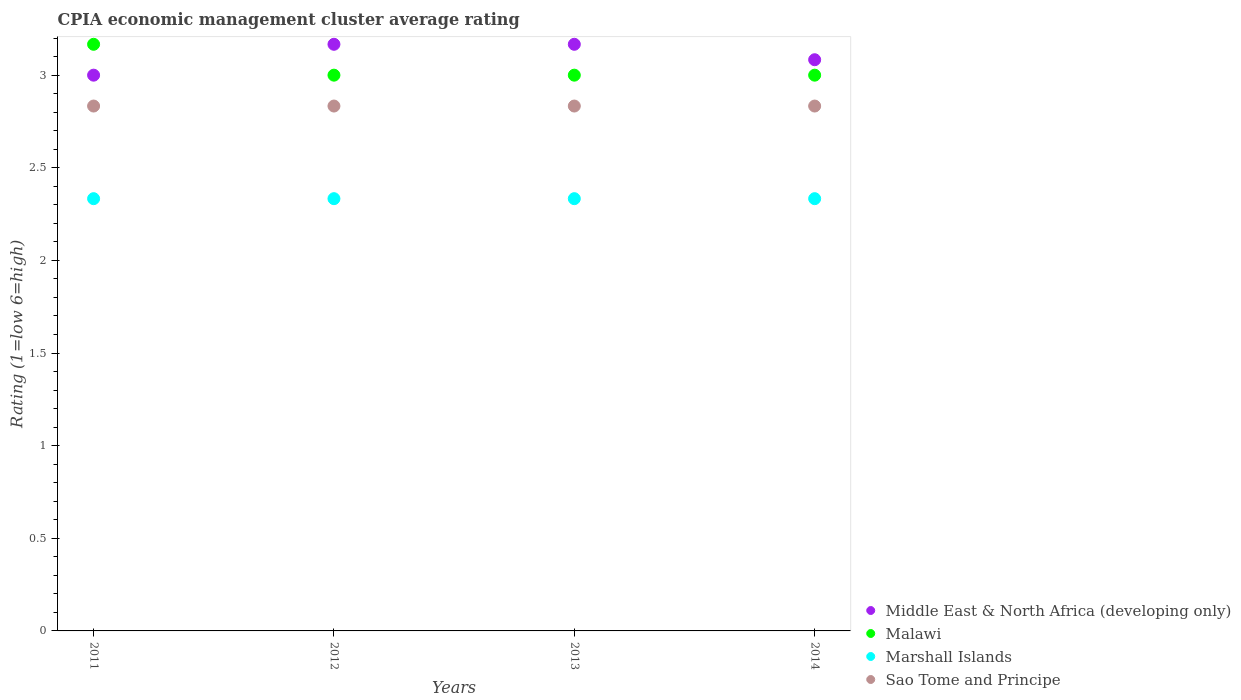How many different coloured dotlines are there?
Give a very brief answer. 4. Is the number of dotlines equal to the number of legend labels?
Keep it short and to the point. Yes. Across all years, what is the maximum CPIA rating in Malawi?
Provide a succinct answer. 3.17. Across all years, what is the minimum CPIA rating in Middle East & North Africa (developing only)?
Your answer should be compact. 3. In which year was the CPIA rating in Malawi minimum?
Make the answer very short. 2012. What is the total CPIA rating in Sao Tome and Principe in the graph?
Provide a short and direct response. 11.33. What is the difference between the CPIA rating in Sao Tome and Principe in 2011 and that in 2013?
Provide a succinct answer. 0. What is the difference between the CPIA rating in Malawi in 2011 and the CPIA rating in Marshall Islands in 2012?
Keep it short and to the point. 0.83. What is the average CPIA rating in Malawi per year?
Your answer should be very brief. 3.04. In the year 2011, what is the difference between the CPIA rating in Malawi and CPIA rating in Marshall Islands?
Your answer should be very brief. 0.83. In how many years, is the CPIA rating in Sao Tome and Principe greater than 2.2?
Ensure brevity in your answer.  4. What is the ratio of the CPIA rating in Malawi in 2011 to that in 2013?
Keep it short and to the point. 1.06. What is the difference between the highest and the second highest CPIA rating in Malawi?
Your response must be concise. 0.17. What is the difference between the highest and the lowest CPIA rating in Sao Tome and Principe?
Your answer should be very brief. 3.333333329802457e-6. Is it the case that in every year, the sum of the CPIA rating in Sao Tome and Principe and CPIA rating in Marshall Islands  is greater than the sum of CPIA rating in Malawi and CPIA rating in Middle East & North Africa (developing only)?
Give a very brief answer. Yes. Does the CPIA rating in Middle East & North Africa (developing only) monotonically increase over the years?
Make the answer very short. No. Is the CPIA rating in Malawi strictly less than the CPIA rating in Marshall Islands over the years?
Offer a very short reply. No. Are the values on the major ticks of Y-axis written in scientific E-notation?
Provide a short and direct response. No. Does the graph contain any zero values?
Offer a terse response. No. What is the title of the graph?
Your answer should be very brief. CPIA economic management cluster average rating. Does "Tunisia" appear as one of the legend labels in the graph?
Offer a very short reply. No. What is the Rating (1=low 6=high) in Malawi in 2011?
Your answer should be very brief. 3.17. What is the Rating (1=low 6=high) of Marshall Islands in 2011?
Ensure brevity in your answer.  2.33. What is the Rating (1=low 6=high) in Sao Tome and Principe in 2011?
Give a very brief answer. 2.83. What is the Rating (1=low 6=high) of Middle East & North Africa (developing only) in 2012?
Ensure brevity in your answer.  3.17. What is the Rating (1=low 6=high) of Marshall Islands in 2012?
Your answer should be very brief. 2.33. What is the Rating (1=low 6=high) in Sao Tome and Principe in 2012?
Provide a succinct answer. 2.83. What is the Rating (1=low 6=high) in Middle East & North Africa (developing only) in 2013?
Provide a short and direct response. 3.17. What is the Rating (1=low 6=high) in Marshall Islands in 2013?
Your response must be concise. 2.33. What is the Rating (1=low 6=high) in Sao Tome and Principe in 2013?
Keep it short and to the point. 2.83. What is the Rating (1=low 6=high) in Middle East & North Africa (developing only) in 2014?
Your response must be concise. 3.08. What is the Rating (1=low 6=high) in Marshall Islands in 2014?
Offer a very short reply. 2.33. What is the Rating (1=low 6=high) of Sao Tome and Principe in 2014?
Your answer should be compact. 2.83. Across all years, what is the maximum Rating (1=low 6=high) in Middle East & North Africa (developing only)?
Provide a succinct answer. 3.17. Across all years, what is the maximum Rating (1=low 6=high) of Malawi?
Keep it short and to the point. 3.17. Across all years, what is the maximum Rating (1=low 6=high) of Marshall Islands?
Keep it short and to the point. 2.33. Across all years, what is the maximum Rating (1=low 6=high) of Sao Tome and Principe?
Make the answer very short. 2.83. Across all years, what is the minimum Rating (1=low 6=high) of Middle East & North Africa (developing only)?
Provide a succinct answer. 3. Across all years, what is the minimum Rating (1=low 6=high) of Malawi?
Ensure brevity in your answer.  3. Across all years, what is the minimum Rating (1=low 6=high) of Marshall Islands?
Provide a short and direct response. 2.33. Across all years, what is the minimum Rating (1=low 6=high) in Sao Tome and Principe?
Your response must be concise. 2.83. What is the total Rating (1=low 6=high) in Middle East & North Africa (developing only) in the graph?
Offer a very short reply. 12.42. What is the total Rating (1=low 6=high) in Malawi in the graph?
Keep it short and to the point. 12.17. What is the total Rating (1=low 6=high) in Marshall Islands in the graph?
Your response must be concise. 9.33. What is the total Rating (1=low 6=high) of Sao Tome and Principe in the graph?
Keep it short and to the point. 11.33. What is the difference between the Rating (1=low 6=high) in Middle East & North Africa (developing only) in 2011 and that in 2012?
Offer a very short reply. -0.17. What is the difference between the Rating (1=low 6=high) of Malawi in 2011 and that in 2012?
Your answer should be compact. 0.17. What is the difference between the Rating (1=low 6=high) of Marshall Islands in 2011 and that in 2012?
Offer a very short reply. 0. What is the difference between the Rating (1=low 6=high) in Sao Tome and Principe in 2011 and that in 2013?
Offer a very short reply. 0. What is the difference between the Rating (1=low 6=high) of Middle East & North Africa (developing only) in 2011 and that in 2014?
Provide a succinct answer. -0.08. What is the difference between the Rating (1=low 6=high) of Marshall Islands in 2011 and that in 2014?
Your answer should be very brief. 0. What is the difference between the Rating (1=low 6=high) in Marshall Islands in 2012 and that in 2013?
Give a very brief answer. 0. What is the difference between the Rating (1=low 6=high) of Middle East & North Africa (developing only) in 2012 and that in 2014?
Keep it short and to the point. 0.08. What is the difference between the Rating (1=low 6=high) in Malawi in 2012 and that in 2014?
Provide a short and direct response. 0. What is the difference between the Rating (1=low 6=high) of Marshall Islands in 2012 and that in 2014?
Your answer should be very brief. 0. What is the difference between the Rating (1=low 6=high) in Middle East & North Africa (developing only) in 2013 and that in 2014?
Provide a succinct answer. 0.08. What is the difference between the Rating (1=low 6=high) in Malawi in 2013 and that in 2014?
Your answer should be compact. 0. What is the difference between the Rating (1=low 6=high) in Marshall Islands in 2013 and that in 2014?
Give a very brief answer. 0. What is the difference between the Rating (1=low 6=high) in Sao Tome and Principe in 2013 and that in 2014?
Provide a short and direct response. 0. What is the difference between the Rating (1=low 6=high) in Middle East & North Africa (developing only) in 2011 and the Rating (1=low 6=high) in Marshall Islands in 2012?
Offer a very short reply. 0.67. What is the difference between the Rating (1=low 6=high) in Malawi in 2011 and the Rating (1=low 6=high) in Marshall Islands in 2012?
Offer a terse response. 0.83. What is the difference between the Rating (1=low 6=high) in Malawi in 2011 and the Rating (1=low 6=high) in Sao Tome and Principe in 2012?
Keep it short and to the point. 0.33. What is the difference between the Rating (1=low 6=high) of Marshall Islands in 2011 and the Rating (1=low 6=high) of Sao Tome and Principe in 2012?
Your answer should be very brief. -0.5. What is the difference between the Rating (1=low 6=high) in Middle East & North Africa (developing only) in 2011 and the Rating (1=low 6=high) in Malawi in 2013?
Offer a very short reply. 0. What is the difference between the Rating (1=low 6=high) in Malawi in 2011 and the Rating (1=low 6=high) in Sao Tome and Principe in 2013?
Give a very brief answer. 0.33. What is the difference between the Rating (1=low 6=high) of Marshall Islands in 2011 and the Rating (1=low 6=high) of Sao Tome and Principe in 2013?
Offer a terse response. -0.5. What is the difference between the Rating (1=low 6=high) in Marshall Islands in 2011 and the Rating (1=low 6=high) in Sao Tome and Principe in 2014?
Your answer should be compact. -0.5. What is the difference between the Rating (1=low 6=high) in Middle East & North Africa (developing only) in 2012 and the Rating (1=low 6=high) in Malawi in 2013?
Offer a very short reply. 0.17. What is the difference between the Rating (1=low 6=high) of Middle East & North Africa (developing only) in 2012 and the Rating (1=low 6=high) of Marshall Islands in 2013?
Offer a very short reply. 0.83. What is the difference between the Rating (1=low 6=high) in Malawi in 2012 and the Rating (1=low 6=high) in Marshall Islands in 2013?
Your response must be concise. 0.67. What is the difference between the Rating (1=low 6=high) of Middle East & North Africa (developing only) in 2012 and the Rating (1=low 6=high) of Malawi in 2014?
Give a very brief answer. 0.17. What is the difference between the Rating (1=low 6=high) in Middle East & North Africa (developing only) in 2012 and the Rating (1=low 6=high) in Sao Tome and Principe in 2014?
Ensure brevity in your answer.  0.33. What is the difference between the Rating (1=low 6=high) of Malawi in 2012 and the Rating (1=low 6=high) of Marshall Islands in 2014?
Your response must be concise. 0.67. What is the difference between the Rating (1=low 6=high) in Marshall Islands in 2012 and the Rating (1=low 6=high) in Sao Tome and Principe in 2014?
Keep it short and to the point. -0.5. What is the difference between the Rating (1=low 6=high) of Middle East & North Africa (developing only) in 2013 and the Rating (1=low 6=high) of Marshall Islands in 2014?
Offer a very short reply. 0.83. What is the difference between the Rating (1=low 6=high) in Middle East & North Africa (developing only) in 2013 and the Rating (1=low 6=high) in Sao Tome and Principe in 2014?
Offer a very short reply. 0.33. What is the difference between the Rating (1=low 6=high) in Malawi in 2013 and the Rating (1=low 6=high) in Sao Tome and Principe in 2014?
Keep it short and to the point. 0.17. What is the average Rating (1=low 6=high) in Middle East & North Africa (developing only) per year?
Offer a very short reply. 3.1. What is the average Rating (1=low 6=high) in Malawi per year?
Give a very brief answer. 3.04. What is the average Rating (1=low 6=high) in Marshall Islands per year?
Give a very brief answer. 2.33. What is the average Rating (1=low 6=high) of Sao Tome and Principe per year?
Keep it short and to the point. 2.83. In the year 2011, what is the difference between the Rating (1=low 6=high) of Middle East & North Africa (developing only) and Rating (1=low 6=high) of Malawi?
Offer a very short reply. -0.17. In the year 2011, what is the difference between the Rating (1=low 6=high) of Middle East & North Africa (developing only) and Rating (1=low 6=high) of Marshall Islands?
Your answer should be very brief. 0.67. In the year 2011, what is the difference between the Rating (1=low 6=high) in Middle East & North Africa (developing only) and Rating (1=low 6=high) in Sao Tome and Principe?
Make the answer very short. 0.17. In the year 2011, what is the difference between the Rating (1=low 6=high) in Malawi and Rating (1=low 6=high) in Marshall Islands?
Offer a very short reply. 0.83. In the year 2011, what is the difference between the Rating (1=low 6=high) of Malawi and Rating (1=low 6=high) of Sao Tome and Principe?
Your answer should be very brief. 0.33. In the year 2012, what is the difference between the Rating (1=low 6=high) in Middle East & North Africa (developing only) and Rating (1=low 6=high) in Malawi?
Offer a very short reply. 0.17. In the year 2012, what is the difference between the Rating (1=low 6=high) in Malawi and Rating (1=low 6=high) in Marshall Islands?
Offer a very short reply. 0.67. In the year 2012, what is the difference between the Rating (1=low 6=high) in Malawi and Rating (1=low 6=high) in Sao Tome and Principe?
Your answer should be very brief. 0.17. In the year 2012, what is the difference between the Rating (1=low 6=high) of Marshall Islands and Rating (1=low 6=high) of Sao Tome and Principe?
Keep it short and to the point. -0.5. In the year 2013, what is the difference between the Rating (1=low 6=high) in Marshall Islands and Rating (1=low 6=high) in Sao Tome and Principe?
Provide a succinct answer. -0.5. In the year 2014, what is the difference between the Rating (1=low 6=high) of Middle East & North Africa (developing only) and Rating (1=low 6=high) of Malawi?
Your answer should be very brief. 0.08. In the year 2014, what is the difference between the Rating (1=low 6=high) of Middle East & North Africa (developing only) and Rating (1=low 6=high) of Marshall Islands?
Provide a short and direct response. 0.75. What is the ratio of the Rating (1=low 6=high) in Malawi in 2011 to that in 2012?
Your answer should be very brief. 1.06. What is the ratio of the Rating (1=low 6=high) in Middle East & North Africa (developing only) in 2011 to that in 2013?
Make the answer very short. 0.95. What is the ratio of the Rating (1=low 6=high) in Malawi in 2011 to that in 2013?
Ensure brevity in your answer.  1.06. What is the ratio of the Rating (1=low 6=high) in Marshall Islands in 2011 to that in 2013?
Offer a very short reply. 1. What is the ratio of the Rating (1=low 6=high) in Malawi in 2011 to that in 2014?
Provide a short and direct response. 1.06. What is the ratio of the Rating (1=low 6=high) of Marshall Islands in 2011 to that in 2014?
Your answer should be very brief. 1. What is the ratio of the Rating (1=low 6=high) in Malawi in 2012 to that in 2013?
Your response must be concise. 1. What is the ratio of the Rating (1=low 6=high) of Marshall Islands in 2012 to that in 2013?
Provide a succinct answer. 1. What is the ratio of the Rating (1=low 6=high) in Sao Tome and Principe in 2012 to that in 2013?
Provide a short and direct response. 1. What is the ratio of the Rating (1=low 6=high) in Malawi in 2012 to that in 2014?
Your answer should be very brief. 1. What is the ratio of the Rating (1=low 6=high) of Sao Tome and Principe in 2012 to that in 2014?
Make the answer very short. 1. What is the ratio of the Rating (1=low 6=high) of Middle East & North Africa (developing only) in 2013 to that in 2014?
Your answer should be very brief. 1.03. What is the ratio of the Rating (1=low 6=high) of Malawi in 2013 to that in 2014?
Keep it short and to the point. 1. What is the ratio of the Rating (1=low 6=high) of Sao Tome and Principe in 2013 to that in 2014?
Provide a short and direct response. 1. What is the difference between the highest and the second highest Rating (1=low 6=high) in Malawi?
Ensure brevity in your answer.  0.17. What is the difference between the highest and the second highest Rating (1=low 6=high) in Sao Tome and Principe?
Make the answer very short. 0. What is the difference between the highest and the lowest Rating (1=low 6=high) of Middle East & North Africa (developing only)?
Provide a succinct answer. 0.17. What is the difference between the highest and the lowest Rating (1=low 6=high) in Malawi?
Ensure brevity in your answer.  0.17. What is the difference between the highest and the lowest Rating (1=low 6=high) in Marshall Islands?
Provide a succinct answer. 0. 